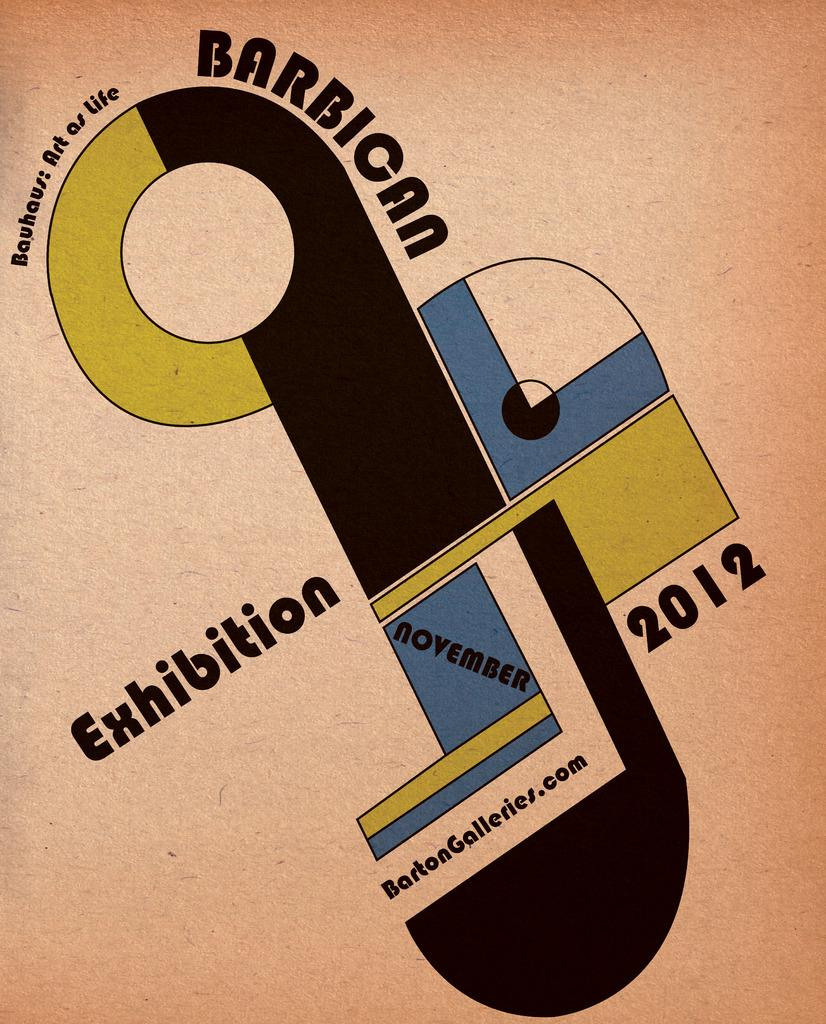<image>
Present a compact description of the photo's key features. A poster for an art gallery has the date November 2012 on it. 